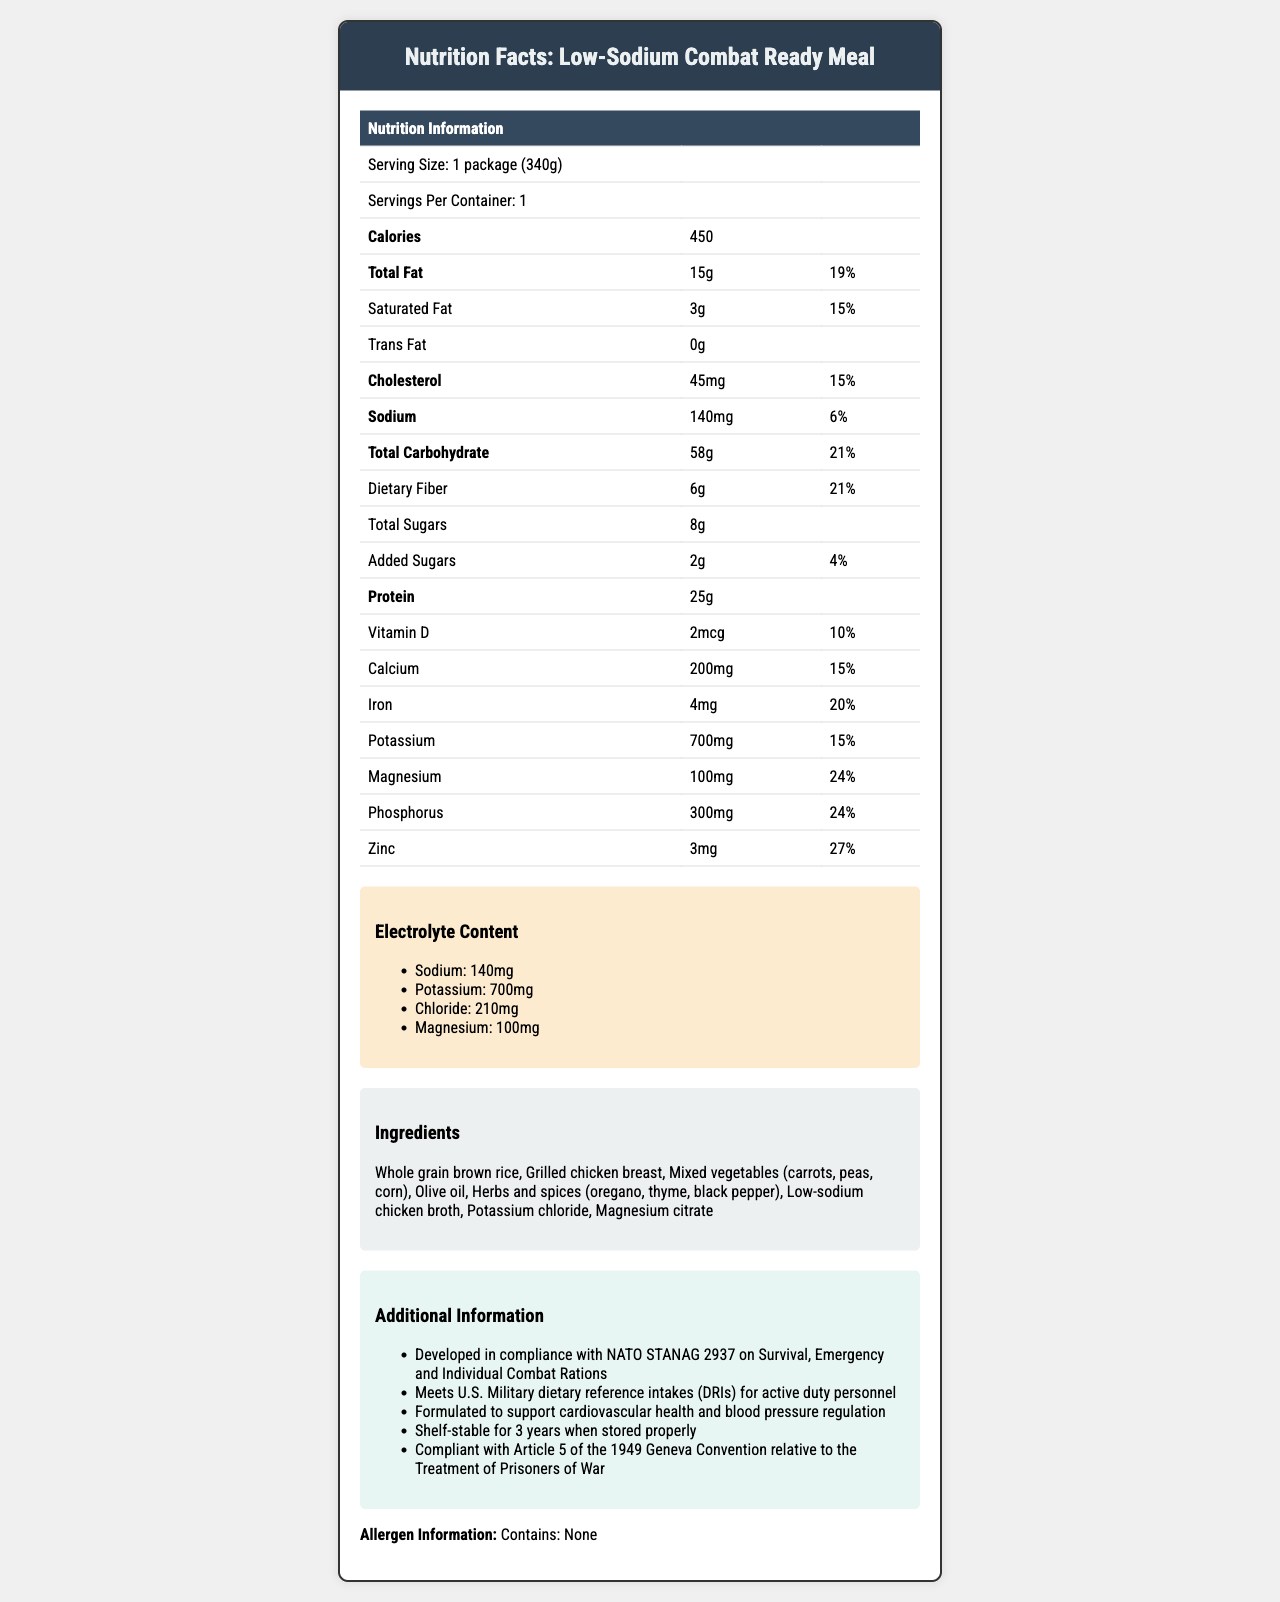What is the serving size of the Low-Sodium Combat Ready Meal? The document specifies the serving size as "1 package (340g)" at the beginning of the nutrition information table.
Answer: 1 package (340g) How many calories does one serving contain? The document lists the number of calories in one serving as 450 under the "Calories" section.
Answer: 450 What is the amount of protein in one serving? The protein content is specified as 25g in the nutrition information table.
Answer: 25g What percentage of the daily value of sodium does this meal contain? The sodium content is given as 140mg, which is 6% of the daily value.
Answer: 6% List three ingredients included in the meal. The list of ingredients includes various items, three of which are Whole grain brown rice, Grilled chicken breast, and Mixed vegetables.
Answer: Whole grain brown rice, Grilled chicken breast, Mixed vegetables (carrots, peas, corn) How much dietary fiber is in the meal? The dietary fiber content is mentioned as 6g, which is also 21% of the daily value.
Answer: 6g Which electrolyte is present in the highest amount per serving? The electrolyte content lists potassium at 700mg, which is the highest among the electrolytes listed.
Answer: Potassium Given the nutrient content, what health benefit is specifically targeted by this meal? The additional information section mentions that the meal is formulated to support cardiovascular health and blood pressure regulation.
Answer: Cardiovascular health and blood pressure regulation Is there any allergen information provided for this meal? The document clearly states "Contains: None" in the allergen information section.
Answer: Contains: None Which of the following nutrients has the highest daily value percentage: calcium, magnesium, or zinc? A. Calcium B. Magnesium C. Zinc Zinc has a daily value percentage of 27%, whereas calcium has 15% and magnesium has 24%.
Answer: C. Zinc Which regulatory compliance is mentioned concerning the treatment of prisoners of war? A. Article 1 of the Geneva Convention B. Article 5 of the Geneva Convention C. NATO STANAG 2937 The additional information section states that the meal is compliant with Article 5 of the 1949 Geneva Convention relative to the Treatment of Prisoners of War.
Answer: B. Article 5 of the Geneva Convention Does the document provide shelf-life information for the meal? The document notes that the meal is shelf-stable for 3 years when stored properly.
Answer: Yes Summarize the key aspects of this meal as detailed in the document. This summary captures the essential details about the meal's nutritional content, health benefits, regulatory compliance, and shelf stability as presented in the document.
Answer: The Low-Sodium Combat Ready Meal provides key nutrients with a focus on low sodium for military personnel with hypertension. It includes 450 calories per package, has high protein and dietary fiber content, and is made with healthy ingredients like whole grains, chicken, and vegetables. It supports cardiovascular health, meets NATO, U.S. Military dietary standards, and has a 3-year shelf life. How much chloride is contained in the meal? The electrolyte content section lists chloride as one of the electrolytes, with a content of 210mg.
Answer: 210mg Based on the document, can we determine whether this meal is suitable for a vegetarian? The document lists ingredients and allergen information but does not explicitly state whether it is suitable for vegetarians, especially considering the presence of grilled chicken breast.
Answer: Cannot be determined 